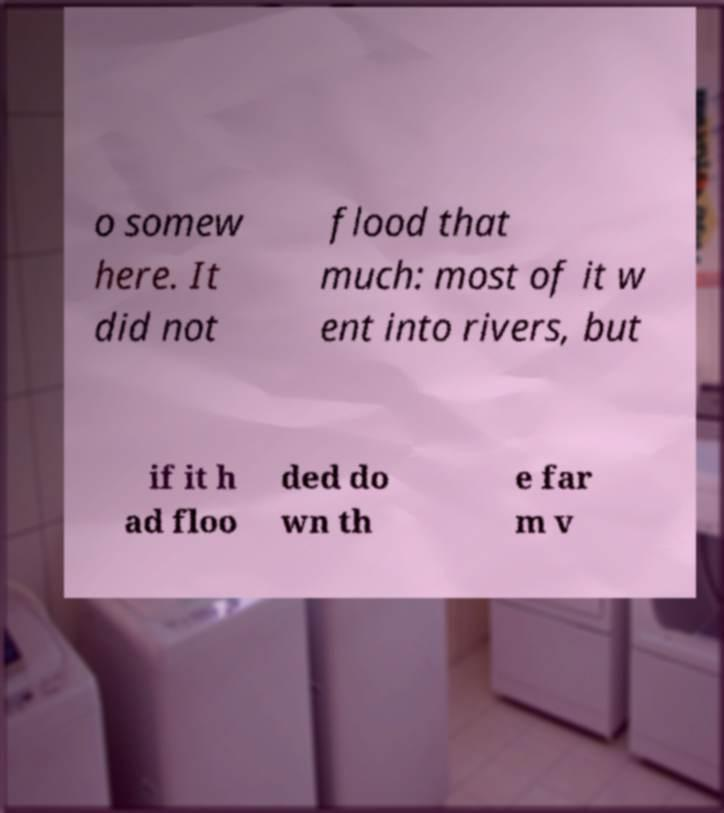Could you assist in decoding the text presented in this image and type it out clearly? o somew here. It did not flood that much: most of it w ent into rivers, but if it h ad floo ded do wn th e far m v 